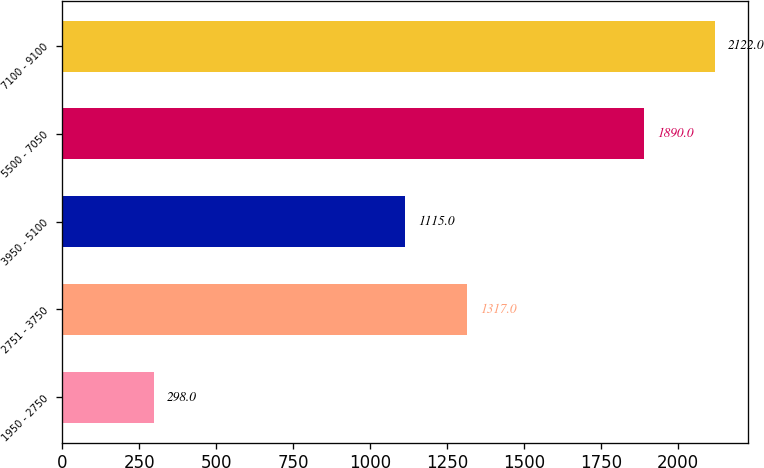Convert chart. <chart><loc_0><loc_0><loc_500><loc_500><bar_chart><fcel>1950 - 2750<fcel>2751 - 3750<fcel>3950 - 5100<fcel>5500 - 7050<fcel>7100 - 9100<nl><fcel>298<fcel>1317<fcel>1115<fcel>1890<fcel>2122<nl></chart> 